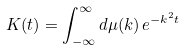Convert formula to latex. <formula><loc_0><loc_0><loc_500><loc_500>K ( t ) = \int _ { - \infty } ^ { \infty } d \mu ( k ) \, e ^ { - k ^ { 2 } t }</formula> 